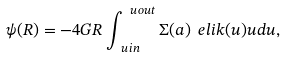Convert formula to latex. <formula><loc_0><loc_0><loc_500><loc_500>\psi ( R ) = - 4 G R \int _ { \ u i n } ^ { \ u o u t } { \Sigma ( a ) \ e l i k ( u ) u d u } ,</formula> 